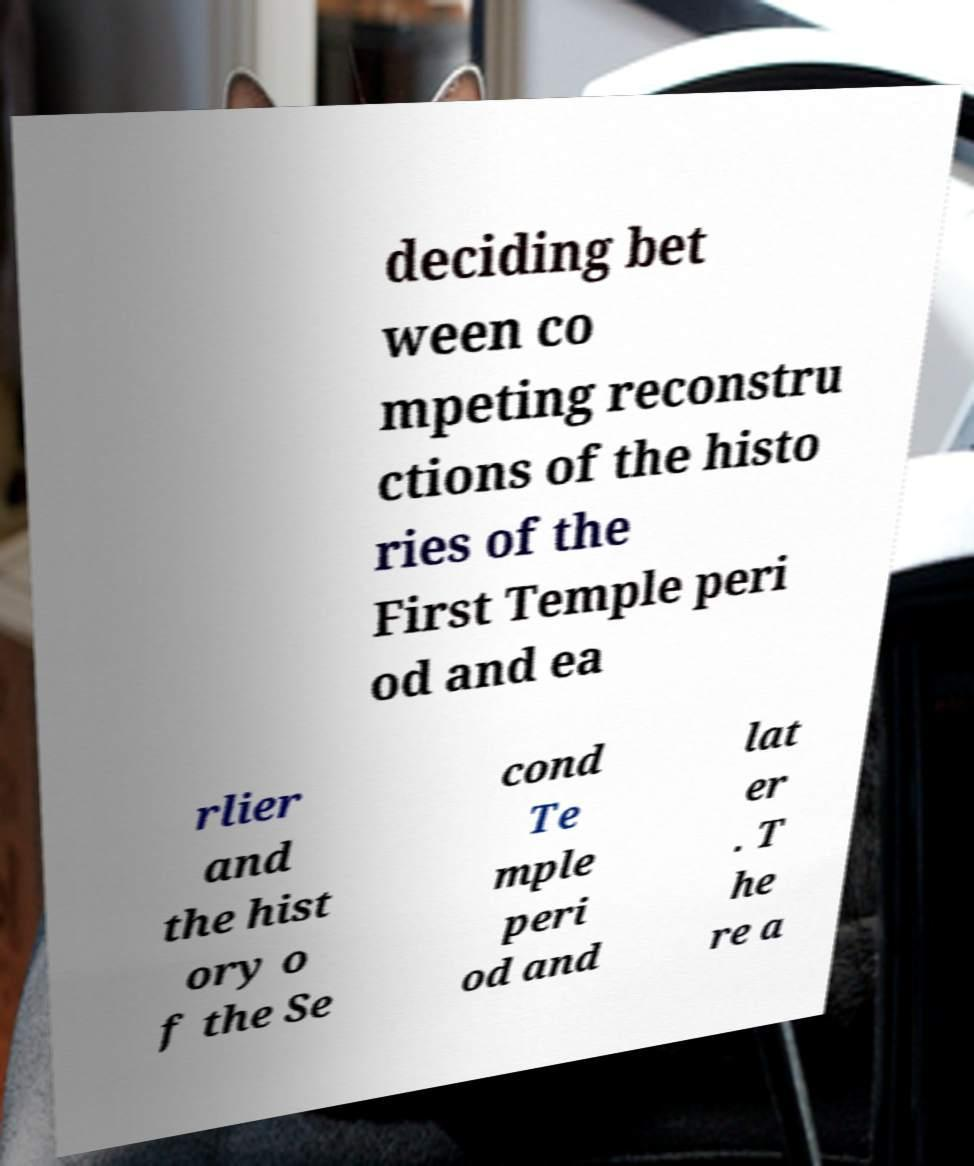Could you extract and type out the text from this image? deciding bet ween co mpeting reconstru ctions of the histo ries of the First Temple peri od and ea rlier and the hist ory o f the Se cond Te mple peri od and lat er . T he re a 